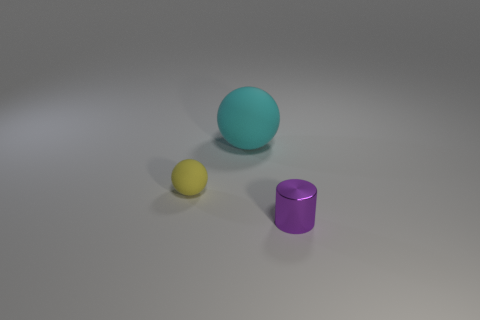What is the shape of the yellow thing that is the same size as the purple cylinder? sphere 